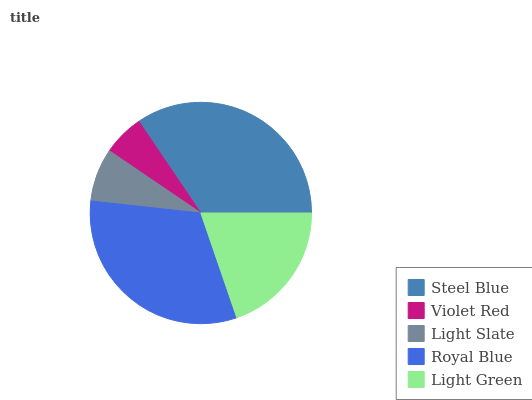Is Violet Red the minimum?
Answer yes or no. Yes. Is Steel Blue the maximum?
Answer yes or no. Yes. Is Light Slate the minimum?
Answer yes or no. No. Is Light Slate the maximum?
Answer yes or no. No. Is Light Slate greater than Violet Red?
Answer yes or no. Yes. Is Violet Red less than Light Slate?
Answer yes or no. Yes. Is Violet Red greater than Light Slate?
Answer yes or no. No. Is Light Slate less than Violet Red?
Answer yes or no. No. Is Light Green the high median?
Answer yes or no. Yes. Is Light Green the low median?
Answer yes or no. Yes. Is Light Slate the high median?
Answer yes or no. No. Is Royal Blue the low median?
Answer yes or no. No. 